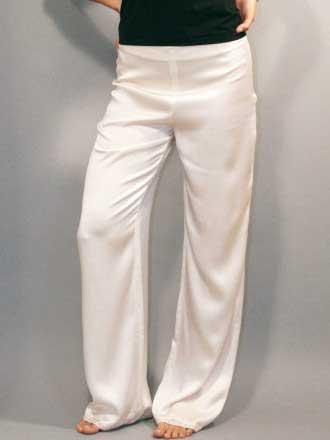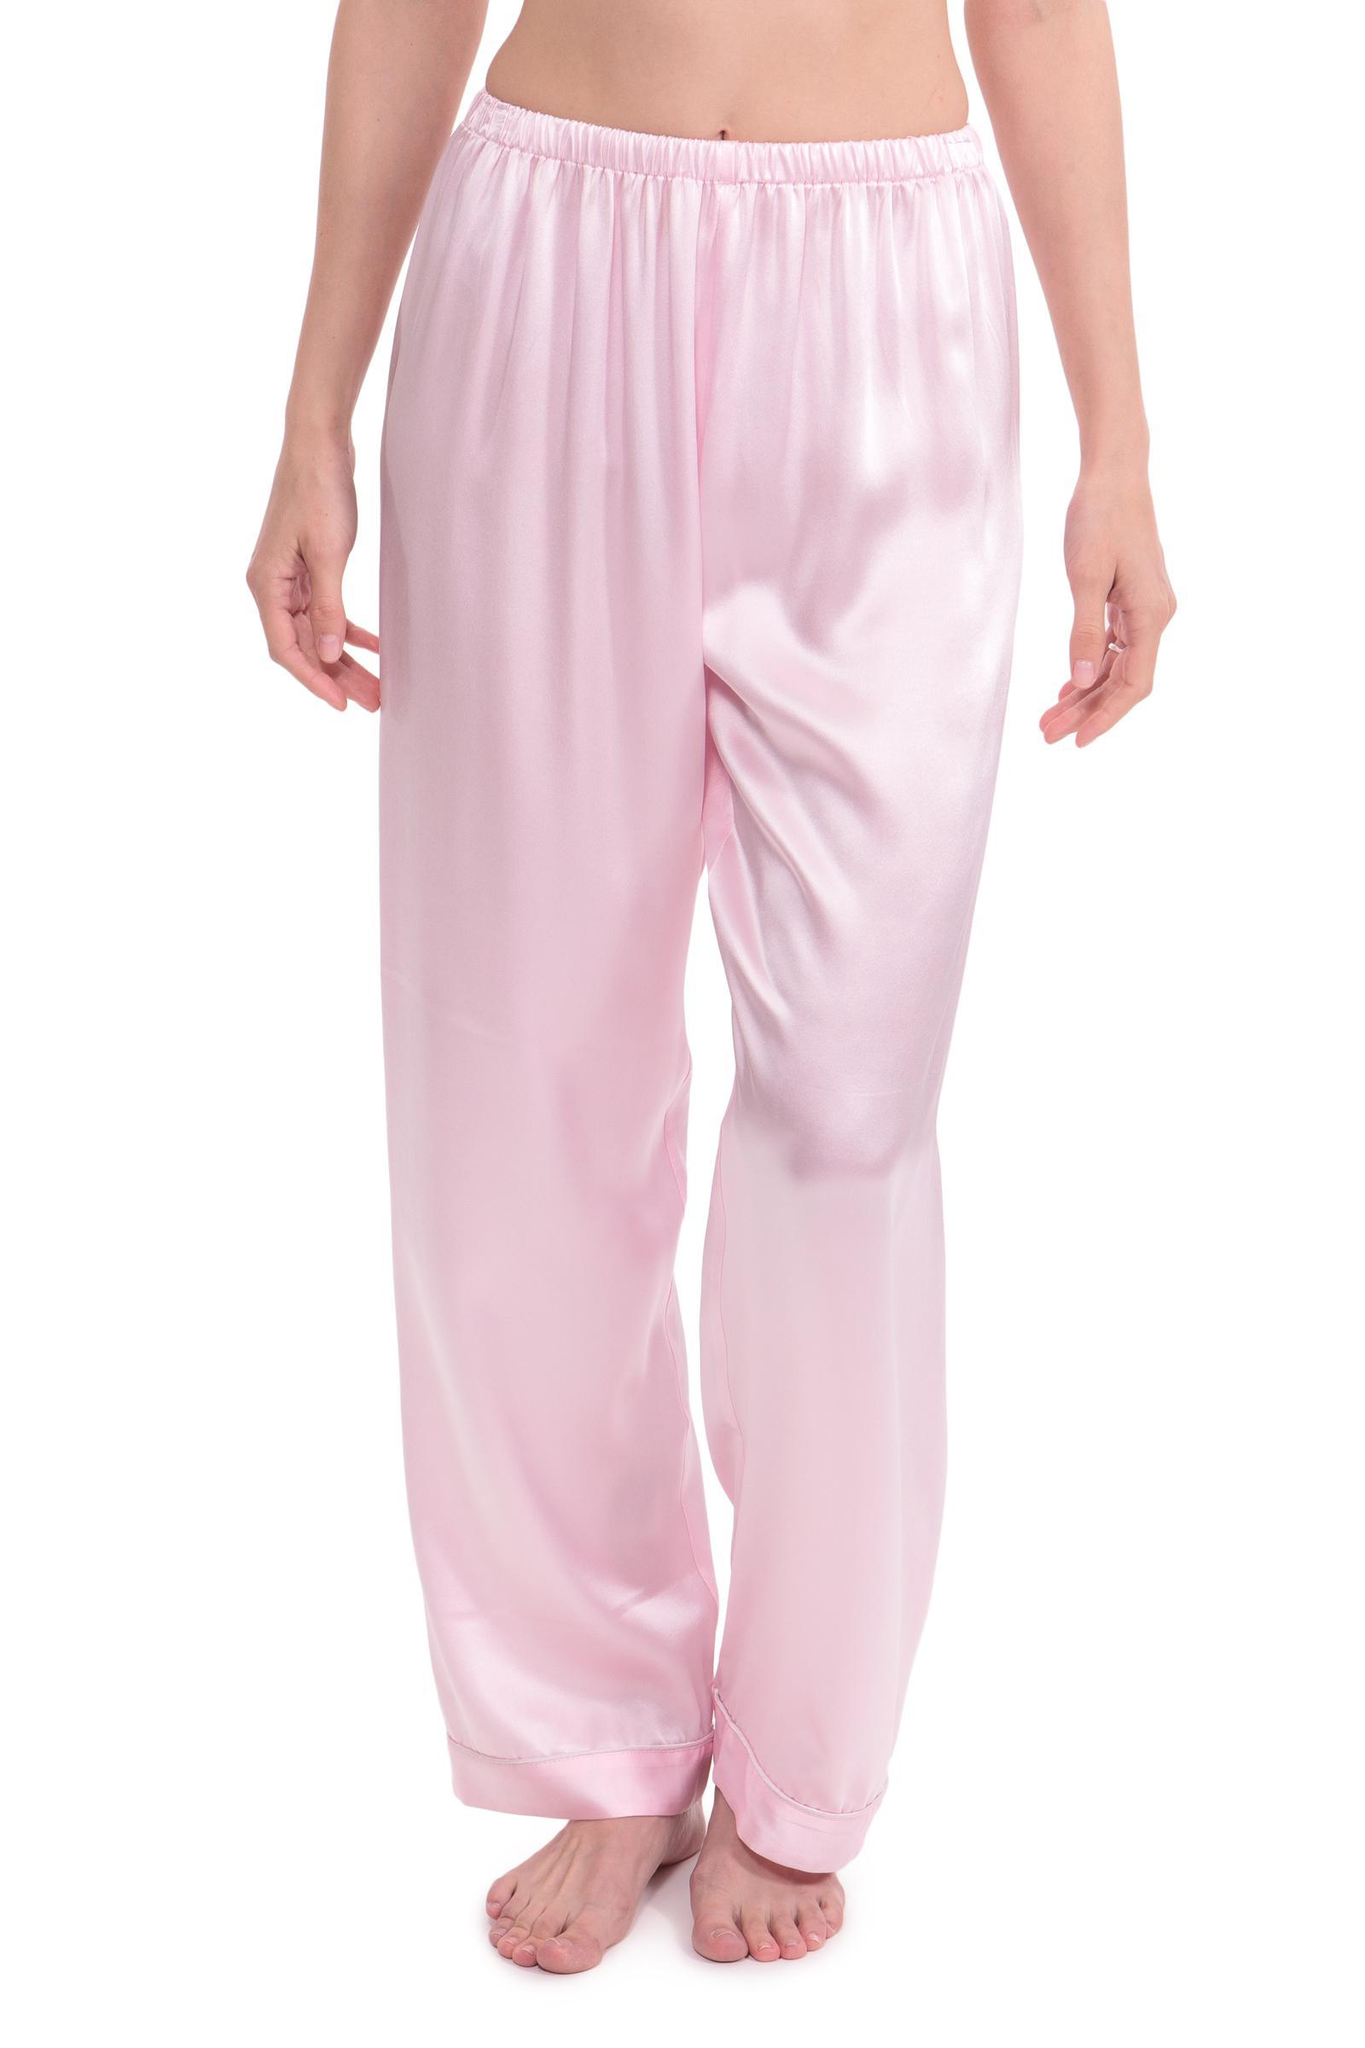The first image is the image on the left, the second image is the image on the right. Analyze the images presented: Is the assertion "The left image shows a woman modeling matching pajama top and bottom." valid? Answer yes or no. No. 